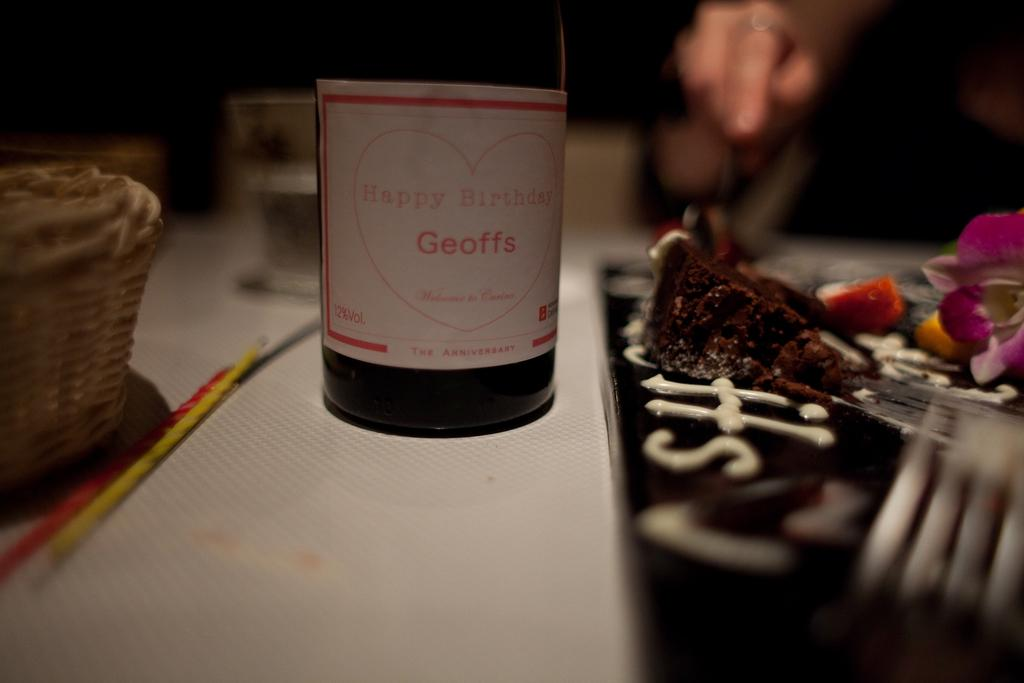Provide a one-sentence caption for the provided image. A bottle of wine is labeled happy Birthday Geoffe inside of a red heart. 